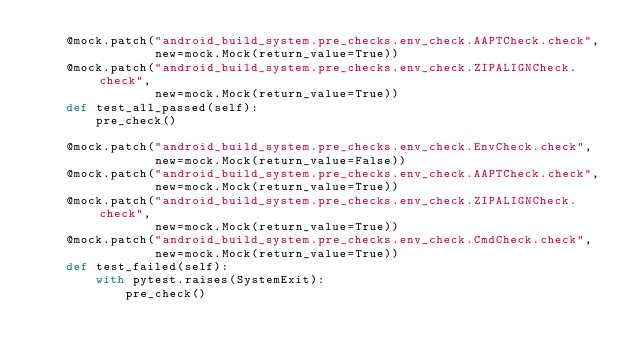Convert code to text. <code><loc_0><loc_0><loc_500><loc_500><_Python_>    @mock.patch("android_build_system.pre_checks.env_check.AAPTCheck.check",
                new=mock.Mock(return_value=True))
    @mock.patch("android_build_system.pre_checks.env_check.ZIPALIGNCheck.check",
                new=mock.Mock(return_value=True))
    def test_all_passed(self):
        pre_check()

    @mock.patch("android_build_system.pre_checks.env_check.EnvCheck.check",
                new=mock.Mock(return_value=False))
    @mock.patch("android_build_system.pre_checks.env_check.AAPTCheck.check",
                new=mock.Mock(return_value=True))
    @mock.patch("android_build_system.pre_checks.env_check.ZIPALIGNCheck.check",
                new=mock.Mock(return_value=True))
    @mock.patch("android_build_system.pre_checks.env_check.CmdCheck.check",
                new=mock.Mock(return_value=True))
    def test_failed(self):
        with pytest.raises(SystemExit):
            pre_check()
</code> 